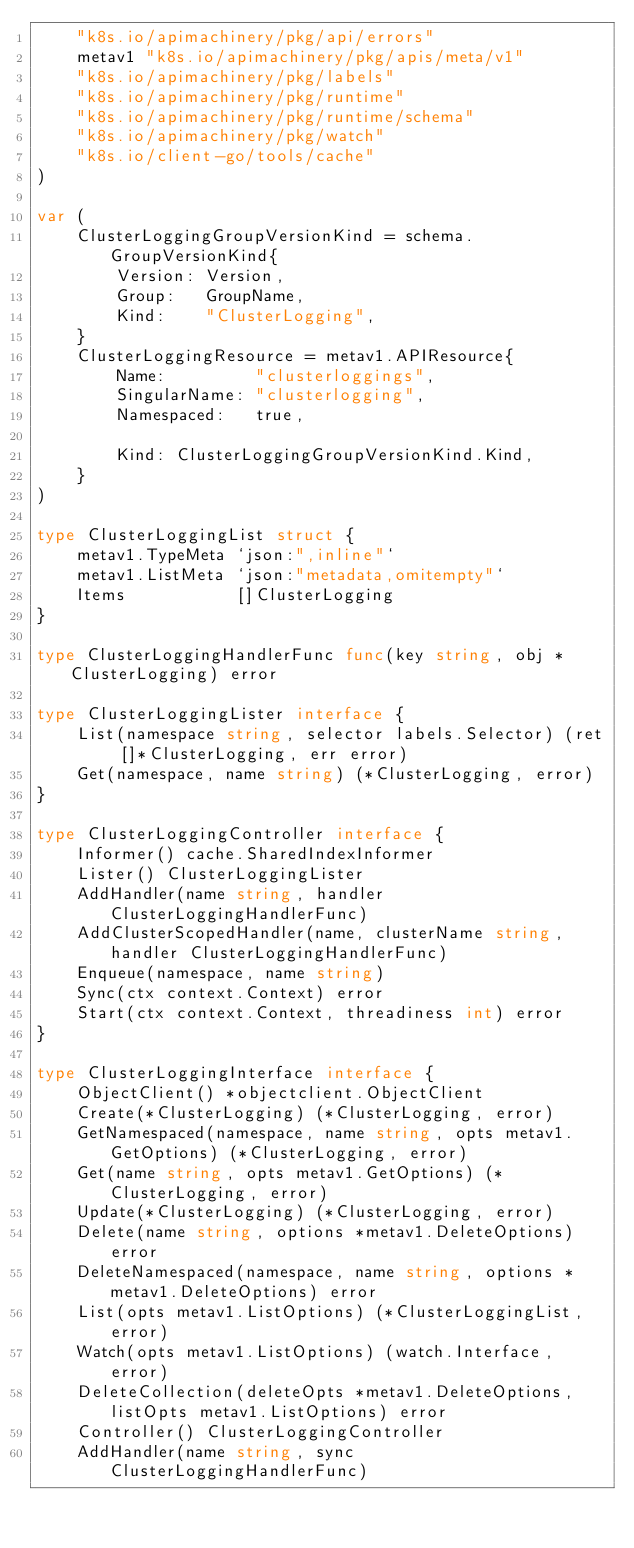Convert code to text. <code><loc_0><loc_0><loc_500><loc_500><_Go_>	"k8s.io/apimachinery/pkg/api/errors"
	metav1 "k8s.io/apimachinery/pkg/apis/meta/v1"
	"k8s.io/apimachinery/pkg/labels"
	"k8s.io/apimachinery/pkg/runtime"
	"k8s.io/apimachinery/pkg/runtime/schema"
	"k8s.io/apimachinery/pkg/watch"
	"k8s.io/client-go/tools/cache"
)

var (
	ClusterLoggingGroupVersionKind = schema.GroupVersionKind{
		Version: Version,
		Group:   GroupName,
		Kind:    "ClusterLogging",
	}
	ClusterLoggingResource = metav1.APIResource{
		Name:         "clusterloggings",
		SingularName: "clusterlogging",
		Namespaced:   true,

		Kind: ClusterLoggingGroupVersionKind.Kind,
	}
)

type ClusterLoggingList struct {
	metav1.TypeMeta `json:",inline"`
	metav1.ListMeta `json:"metadata,omitempty"`
	Items           []ClusterLogging
}

type ClusterLoggingHandlerFunc func(key string, obj *ClusterLogging) error

type ClusterLoggingLister interface {
	List(namespace string, selector labels.Selector) (ret []*ClusterLogging, err error)
	Get(namespace, name string) (*ClusterLogging, error)
}

type ClusterLoggingController interface {
	Informer() cache.SharedIndexInformer
	Lister() ClusterLoggingLister
	AddHandler(name string, handler ClusterLoggingHandlerFunc)
	AddClusterScopedHandler(name, clusterName string, handler ClusterLoggingHandlerFunc)
	Enqueue(namespace, name string)
	Sync(ctx context.Context) error
	Start(ctx context.Context, threadiness int) error
}

type ClusterLoggingInterface interface {
	ObjectClient() *objectclient.ObjectClient
	Create(*ClusterLogging) (*ClusterLogging, error)
	GetNamespaced(namespace, name string, opts metav1.GetOptions) (*ClusterLogging, error)
	Get(name string, opts metav1.GetOptions) (*ClusterLogging, error)
	Update(*ClusterLogging) (*ClusterLogging, error)
	Delete(name string, options *metav1.DeleteOptions) error
	DeleteNamespaced(namespace, name string, options *metav1.DeleteOptions) error
	List(opts metav1.ListOptions) (*ClusterLoggingList, error)
	Watch(opts metav1.ListOptions) (watch.Interface, error)
	DeleteCollection(deleteOpts *metav1.DeleteOptions, listOpts metav1.ListOptions) error
	Controller() ClusterLoggingController
	AddHandler(name string, sync ClusterLoggingHandlerFunc)</code> 